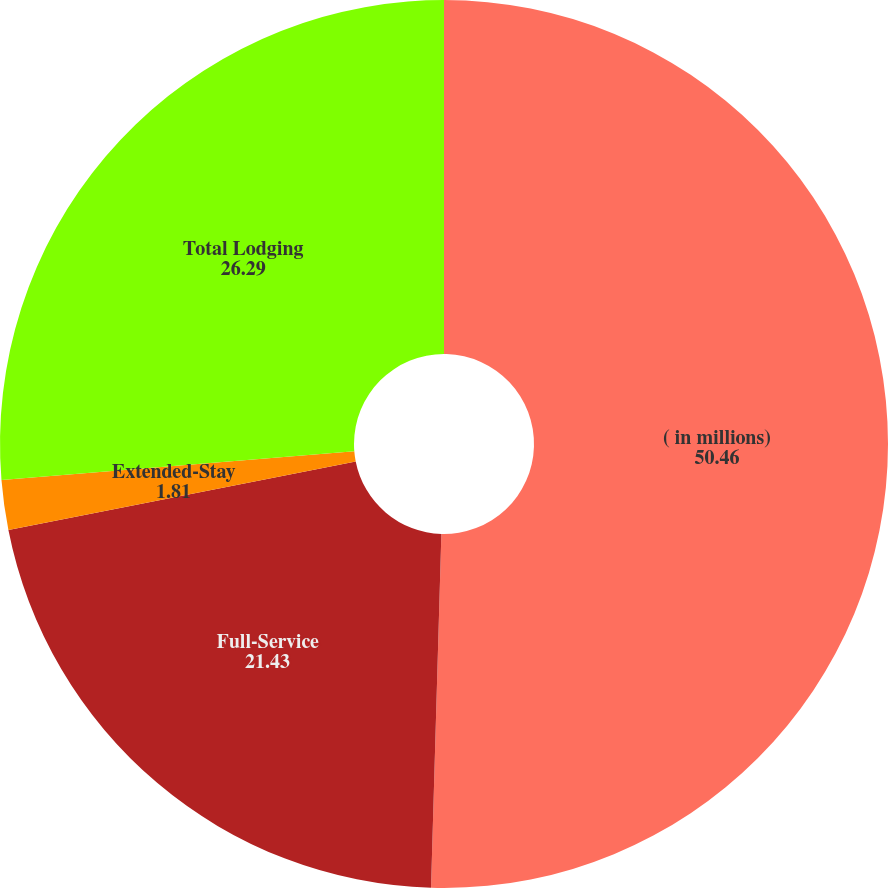Convert chart to OTSL. <chart><loc_0><loc_0><loc_500><loc_500><pie_chart><fcel>( in millions)<fcel>Full-Service<fcel>Extended-Stay<fcel>Total Lodging<nl><fcel>50.46%<fcel>21.43%<fcel>1.81%<fcel>26.29%<nl></chart> 